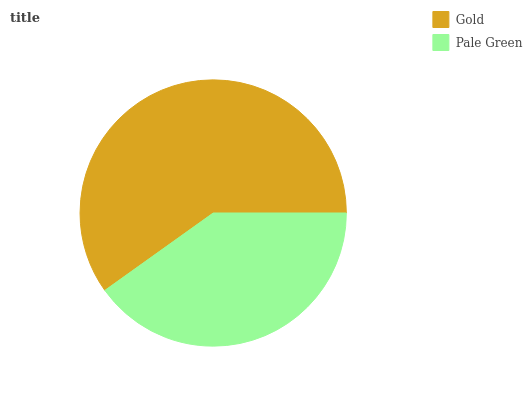Is Pale Green the minimum?
Answer yes or no. Yes. Is Gold the maximum?
Answer yes or no. Yes. Is Pale Green the maximum?
Answer yes or no. No. Is Gold greater than Pale Green?
Answer yes or no. Yes. Is Pale Green less than Gold?
Answer yes or no. Yes. Is Pale Green greater than Gold?
Answer yes or no. No. Is Gold less than Pale Green?
Answer yes or no. No. Is Gold the high median?
Answer yes or no. Yes. Is Pale Green the low median?
Answer yes or no. Yes. Is Pale Green the high median?
Answer yes or no. No. Is Gold the low median?
Answer yes or no. No. 